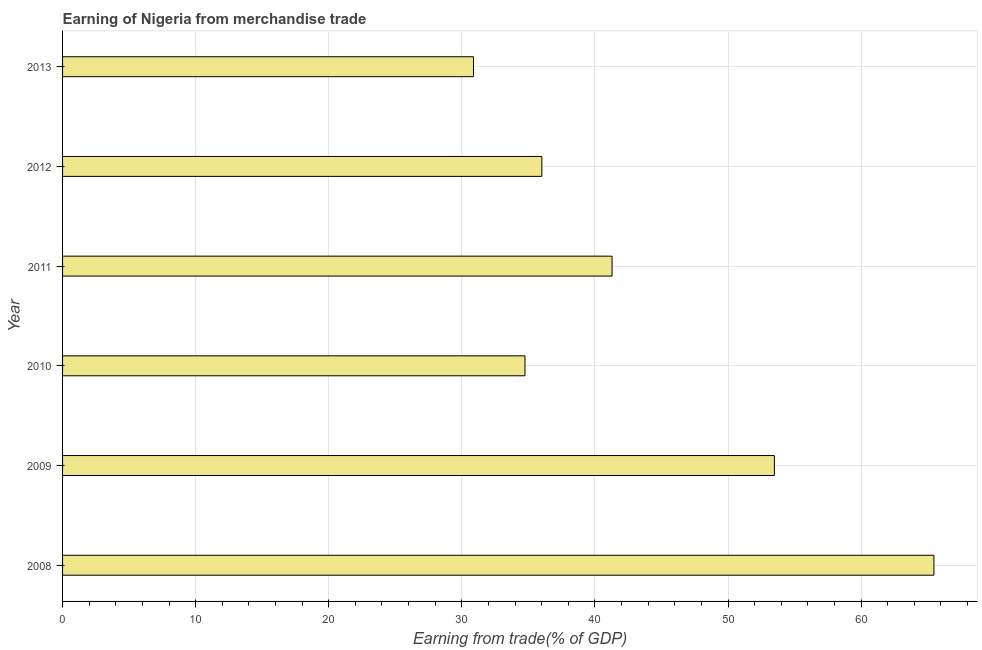Does the graph contain any zero values?
Your answer should be very brief. No. What is the title of the graph?
Provide a short and direct response. Earning of Nigeria from merchandise trade. What is the label or title of the X-axis?
Offer a very short reply. Earning from trade(% of GDP). What is the earning from merchandise trade in 2008?
Your response must be concise. 65.47. Across all years, what is the maximum earning from merchandise trade?
Provide a succinct answer. 65.47. Across all years, what is the minimum earning from merchandise trade?
Give a very brief answer. 30.88. In which year was the earning from merchandise trade minimum?
Your answer should be very brief. 2013. What is the sum of the earning from merchandise trade?
Ensure brevity in your answer.  261.88. What is the difference between the earning from merchandise trade in 2008 and 2013?
Provide a succinct answer. 34.6. What is the average earning from merchandise trade per year?
Provide a short and direct response. 43.65. What is the median earning from merchandise trade?
Your answer should be compact. 38.65. What is the ratio of the earning from merchandise trade in 2009 to that in 2012?
Provide a succinct answer. 1.49. Is the difference between the earning from merchandise trade in 2012 and 2013 greater than the difference between any two years?
Offer a very short reply. No. What is the difference between the highest and the second highest earning from merchandise trade?
Your answer should be compact. 11.99. What is the difference between the highest and the lowest earning from merchandise trade?
Keep it short and to the point. 34.6. In how many years, is the earning from merchandise trade greater than the average earning from merchandise trade taken over all years?
Offer a very short reply. 2. How many bars are there?
Your response must be concise. 6. Are all the bars in the graph horizontal?
Your answer should be very brief. Yes. What is the Earning from trade(% of GDP) of 2008?
Your answer should be compact. 65.47. What is the Earning from trade(% of GDP) in 2009?
Ensure brevity in your answer.  53.49. What is the Earning from trade(% of GDP) of 2010?
Provide a short and direct response. 34.75. What is the Earning from trade(% of GDP) of 2011?
Give a very brief answer. 41.29. What is the Earning from trade(% of GDP) in 2012?
Your response must be concise. 36.01. What is the Earning from trade(% of GDP) in 2013?
Provide a short and direct response. 30.88. What is the difference between the Earning from trade(% of GDP) in 2008 and 2009?
Your response must be concise. 11.99. What is the difference between the Earning from trade(% of GDP) in 2008 and 2010?
Offer a very short reply. 30.73. What is the difference between the Earning from trade(% of GDP) in 2008 and 2011?
Make the answer very short. 24.18. What is the difference between the Earning from trade(% of GDP) in 2008 and 2012?
Give a very brief answer. 29.46. What is the difference between the Earning from trade(% of GDP) in 2008 and 2013?
Your answer should be compact. 34.6. What is the difference between the Earning from trade(% of GDP) in 2009 and 2010?
Ensure brevity in your answer.  18.74. What is the difference between the Earning from trade(% of GDP) in 2009 and 2011?
Offer a very short reply. 12.2. What is the difference between the Earning from trade(% of GDP) in 2009 and 2012?
Make the answer very short. 17.47. What is the difference between the Earning from trade(% of GDP) in 2009 and 2013?
Offer a terse response. 22.61. What is the difference between the Earning from trade(% of GDP) in 2010 and 2011?
Your answer should be compact. -6.54. What is the difference between the Earning from trade(% of GDP) in 2010 and 2012?
Your answer should be very brief. -1.27. What is the difference between the Earning from trade(% of GDP) in 2010 and 2013?
Offer a very short reply. 3.87. What is the difference between the Earning from trade(% of GDP) in 2011 and 2012?
Your answer should be compact. 5.28. What is the difference between the Earning from trade(% of GDP) in 2011 and 2013?
Provide a short and direct response. 10.41. What is the difference between the Earning from trade(% of GDP) in 2012 and 2013?
Make the answer very short. 5.14. What is the ratio of the Earning from trade(% of GDP) in 2008 to that in 2009?
Ensure brevity in your answer.  1.22. What is the ratio of the Earning from trade(% of GDP) in 2008 to that in 2010?
Provide a succinct answer. 1.88. What is the ratio of the Earning from trade(% of GDP) in 2008 to that in 2011?
Your answer should be compact. 1.59. What is the ratio of the Earning from trade(% of GDP) in 2008 to that in 2012?
Ensure brevity in your answer.  1.82. What is the ratio of the Earning from trade(% of GDP) in 2008 to that in 2013?
Your response must be concise. 2.12. What is the ratio of the Earning from trade(% of GDP) in 2009 to that in 2010?
Offer a very short reply. 1.54. What is the ratio of the Earning from trade(% of GDP) in 2009 to that in 2011?
Give a very brief answer. 1.29. What is the ratio of the Earning from trade(% of GDP) in 2009 to that in 2012?
Provide a short and direct response. 1.49. What is the ratio of the Earning from trade(% of GDP) in 2009 to that in 2013?
Ensure brevity in your answer.  1.73. What is the ratio of the Earning from trade(% of GDP) in 2010 to that in 2011?
Ensure brevity in your answer.  0.84. What is the ratio of the Earning from trade(% of GDP) in 2011 to that in 2012?
Your answer should be compact. 1.15. What is the ratio of the Earning from trade(% of GDP) in 2011 to that in 2013?
Ensure brevity in your answer.  1.34. What is the ratio of the Earning from trade(% of GDP) in 2012 to that in 2013?
Provide a short and direct response. 1.17. 